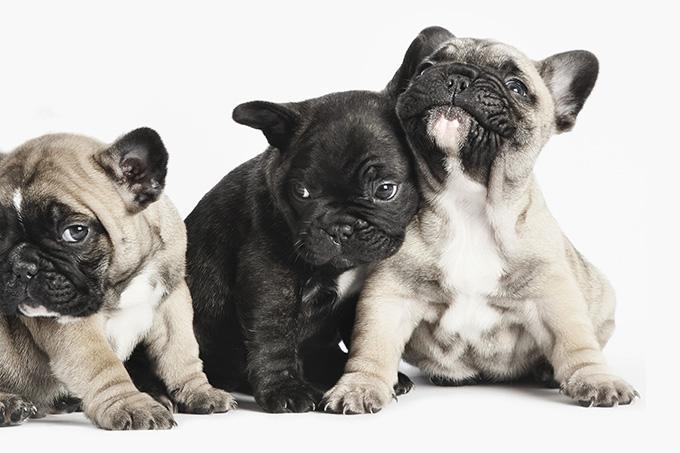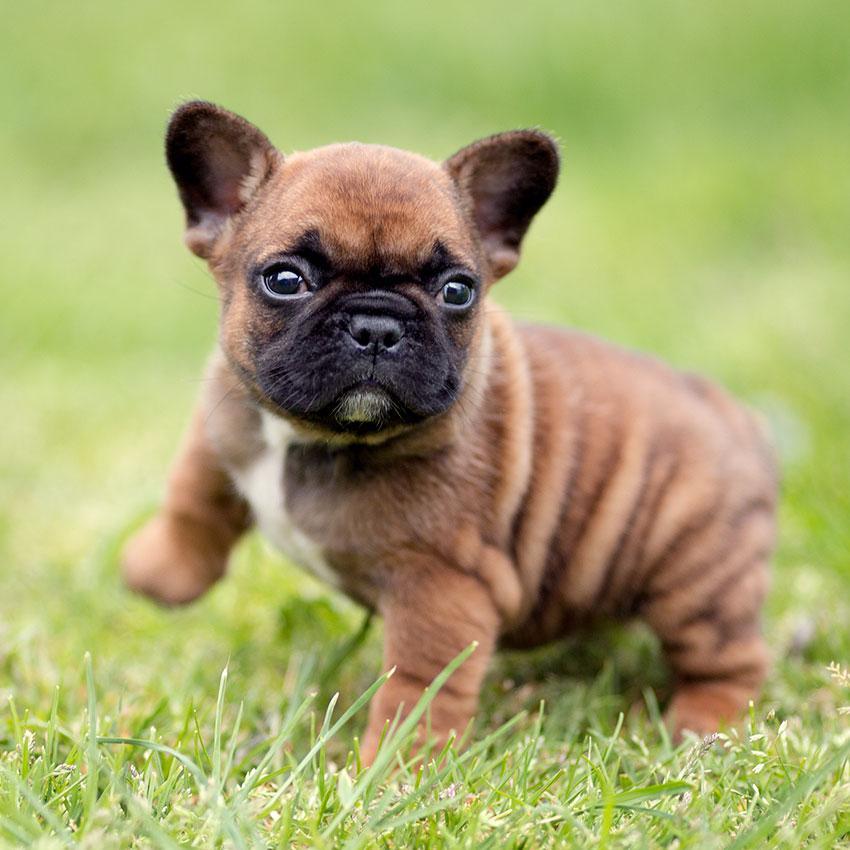The first image is the image on the left, the second image is the image on the right. Given the left and right images, does the statement "An image shows a trio of puppies with a black one in the middle." hold true? Answer yes or no. Yes. The first image is the image on the left, the second image is the image on the right. For the images displayed, is the sentence "Exactly one puppy is standing alone in the grass." factually correct? Answer yes or no. Yes. The first image is the image on the left, the second image is the image on the right. Assess this claim about the two images: "In one of the images, there are more than two puppies.". Correct or not? Answer yes or no. Yes. The first image is the image on the left, the second image is the image on the right. For the images displayed, is the sentence "The dog in the image on the right is on grass." factually correct? Answer yes or no. Yes. 